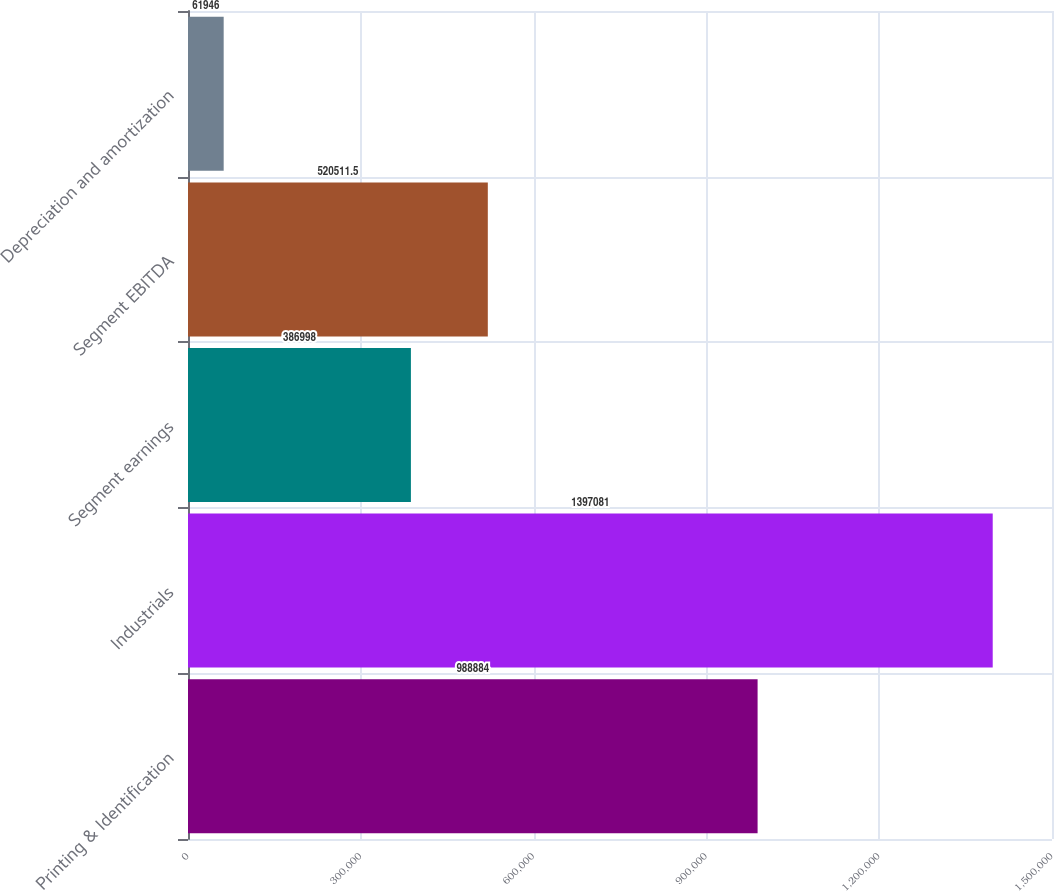Convert chart. <chart><loc_0><loc_0><loc_500><loc_500><bar_chart><fcel>Printing & Identification<fcel>Industrials<fcel>Segment earnings<fcel>Segment EBITDA<fcel>Depreciation and amortization<nl><fcel>988884<fcel>1.39708e+06<fcel>386998<fcel>520512<fcel>61946<nl></chart> 